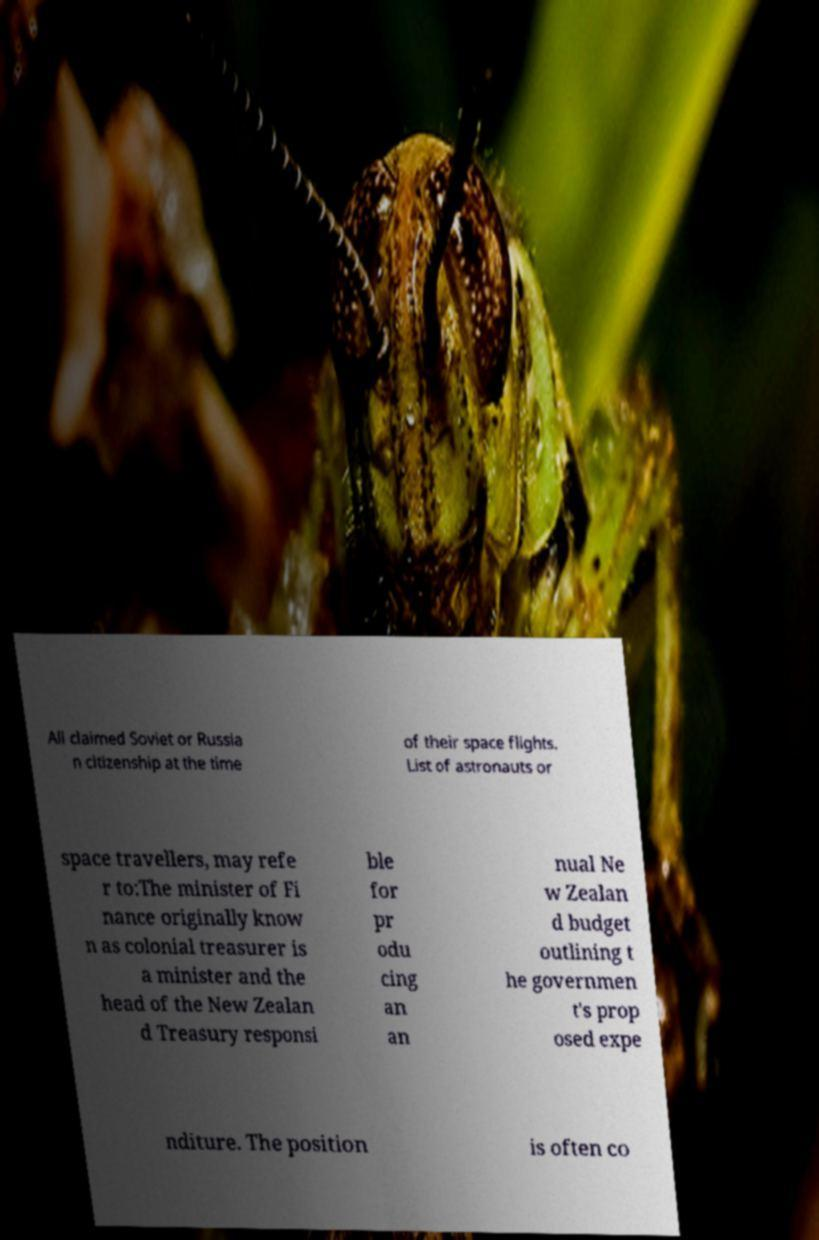Could you assist in decoding the text presented in this image and type it out clearly? All claimed Soviet or Russia n citizenship at the time of their space flights. List of astronauts or space travellers, may refe r to:The minister of Fi nance originally know n as colonial treasurer is a minister and the head of the New Zealan d Treasury responsi ble for pr odu cing an an nual Ne w Zealan d budget outlining t he governmen t's prop osed expe nditure. The position is often co 